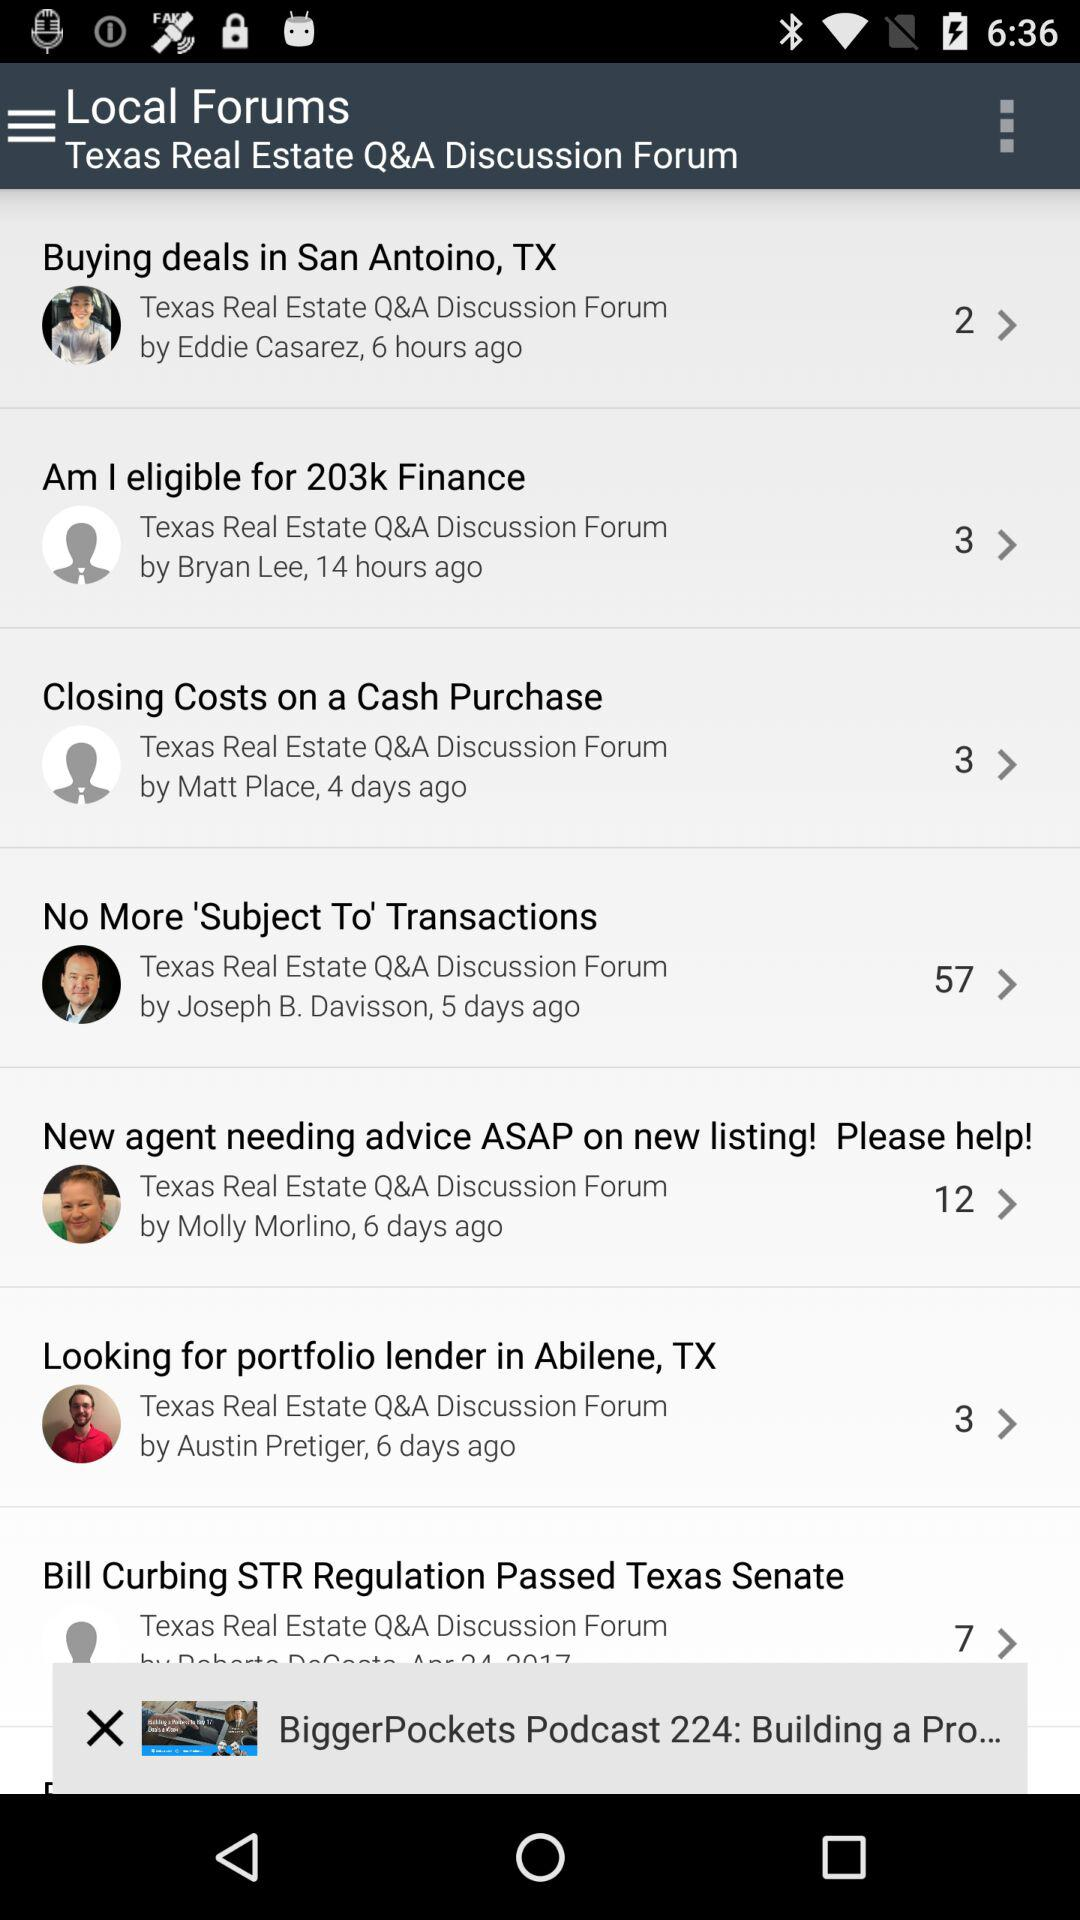How many days ago was the discussion form for "Looking for portfolio lender in Abilene, TX" updated? The discussion form for "Looking for portfolio lender in Abilene, TX" was updated 6 days ago. 